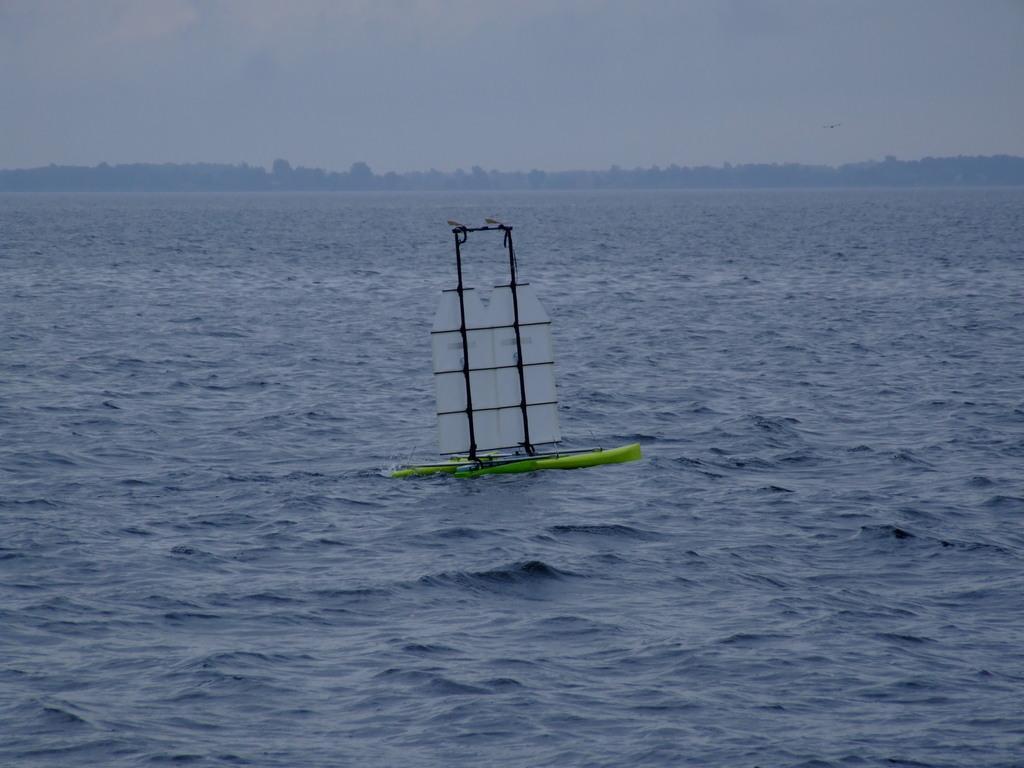How would you summarize this image in a sentence or two? In this image there is a boat on the water, and in the background there are trees and sky. 